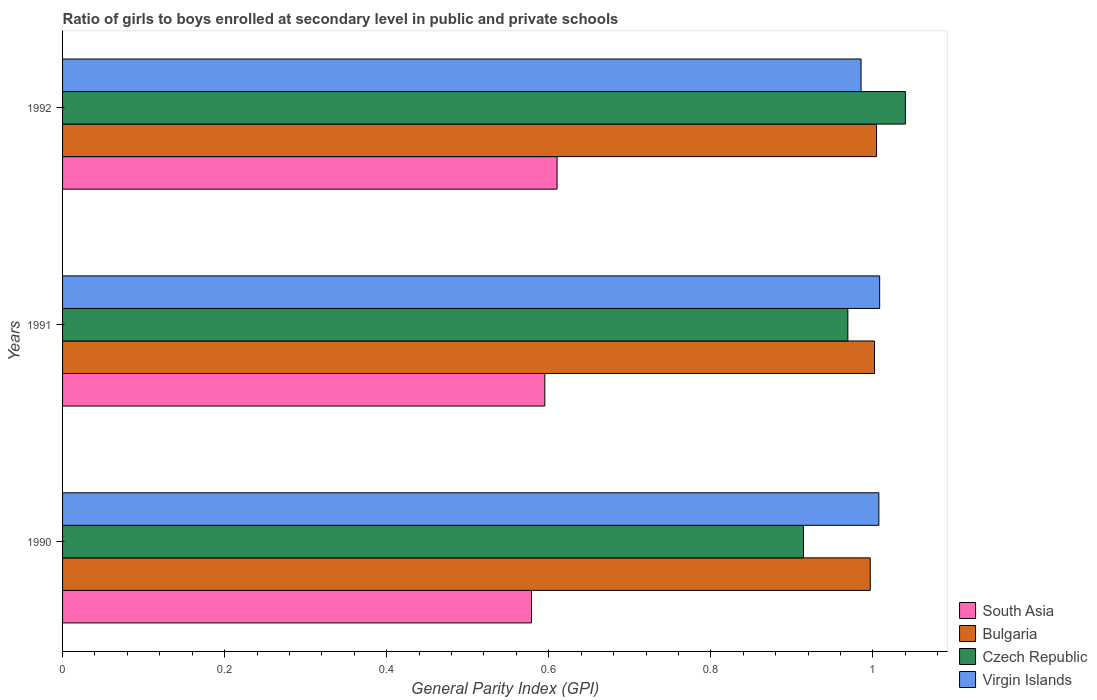How many groups of bars are there?
Your response must be concise. 3. Are the number of bars per tick equal to the number of legend labels?
Your response must be concise. Yes. How many bars are there on the 2nd tick from the bottom?
Provide a short and direct response. 4. In how many cases, is the number of bars for a given year not equal to the number of legend labels?
Your response must be concise. 0. What is the general parity index in South Asia in 1990?
Ensure brevity in your answer.  0.58. Across all years, what is the maximum general parity index in South Asia?
Offer a very short reply. 0.61. Across all years, what is the minimum general parity index in South Asia?
Your answer should be very brief. 0.58. In which year was the general parity index in Virgin Islands maximum?
Provide a succinct answer. 1991. In which year was the general parity index in Virgin Islands minimum?
Keep it short and to the point. 1992. What is the total general parity index in Bulgaria in the graph?
Ensure brevity in your answer.  3. What is the difference between the general parity index in Virgin Islands in 1990 and that in 1992?
Your answer should be compact. 0.02. What is the difference between the general parity index in Bulgaria in 1990 and the general parity index in Czech Republic in 1991?
Make the answer very short. 0.03. What is the average general parity index in Bulgaria per year?
Keep it short and to the point. 1. In the year 1992, what is the difference between the general parity index in South Asia and general parity index in Virgin Islands?
Offer a terse response. -0.38. What is the ratio of the general parity index in Bulgaria in 1990 to that in 1992?
Provide a succinct answer. 0.99. Is the general parity index in Virgin Islands in 1990 less than that in 1991?
Ensure brevity in your answer.  Yes. Is the difference between the general parity index in South Asia in 1990 and 1991 greater than the difference between the general parity index in Virgin Islands in 1990 and 1991?
Ensure brevity in your answer.  No. What is the difference between the highest and the second highest general parity index in South Asia?
Offer a terse response. 0.02. What is the difference between the highest and the lowest general parity index in Czech Republic?
Make the answer very short. 0.13. Is the sum of the general parity index in Bulgaria in 1990 and 1991 greater than the maximum general parity index in Czech Republic across all years?
Your response must be concise. Yes. What does the 2nd bar from the top in 1990 represents?
Your response must be concise. Czech Republic. How many bars are there?
Keep it short and to the point. 12. Are all the bars in the graph horizontal?
Keep it short and to the point. Yes. What is the difference between two consecutive major ticks on the X-axis?
Keep it short and to the point. 0.2. Are the values on the major ticks of X-axis written in scientific E-notation?
Provide a short and direct response. No. Does the graph contain any zero values?
Your answer should be very brief. No. How are the legend labels stacked?
Provide a short and direct response. Vertical. What is the title of the graph?
Provide a short and direct response. Ratio of girls to boys enrolled at secondary level in public and private schools. What is the label or title of the X-axis?
Give a very brief answer. General Parity Index (GPI). What is the label or title of the Y-axis?
Offer a very short reply. Years. What is the General Parity Index (GPI) in South Asia in 1990?
Your answer should be compact. 0.58. What is the General Parity Index (GPI) of Bulgaria in 1990?
Offer a very short reply. 1. What is the General Parity Index (GPI) of Czech Republic in 1990?
Give a very brief answer. 0.91. What is the General Parity Index (GPI) in Virgin Islands in 1990?
Ensure brevity in your answer.  1.01. What is the General Parity Index (GPI) of South Asia in 1991?
Give a very brief answer. 0.6. What is the General Parity Index (GPI) of Bulgaria in 1991?
Make the answer very short. 1. What is the General Parity Index (GPI) in Czech Republic in 1991?
Make the answer very short. 0.97. What is the General Parity Index (GPI) of Virgin Islands in 1991?
Provide a succinct answer. 1.01. What is the General Parity Index (GPI) of South Asia in 1992?
Ensure brevity in your answer.  0.61. What is the General Parity Index (GPI) in Bulgaria in 1992?
Provide a succinct answer. 1. What is the General Parity Index (GPI) of Czech Republic in 1992?
Give a very brief answer. 1.04. What is the General Parity Index (GPI) in Virgin Islands in 1992?
Keep it short and to the point. 0.99. Across all years, what is the maximum General Parity Index (GPI) in South Asia?
Ensure brevity in your answer.  0.61. Across all years, what is the maximum General Parity Index (GPI) of Bulgaria?
Your answer should be very brief. 1. Across all years, what is the maximum General Parity Index (GPI) of Czech Republic?
Ensure brevity in your answer.  1.04. Across all years, what is the maximum General Parity Index (GPI) of Virgin Islands?
Provide a short and direct response. 1.01. Across all years, what is the minimum General Parity Index (GPI) in South Asia?
Offer a terse response. 0.58. Across all years, what is the minimum General Parity Index (GPI) of Bulgaria?
Provide a succinct answer. 1. Across all years, what is the minimum General Parity Index (GPI) in Czech Republic?
Offer a terse response. 0.91. Across all years, what is the minimum General Parity Index (GPI) of Virgin Islands?
Ensure brevity in your answer.  0.99. What is the total General Parity Index (GPI) of South Asia in the graph?
Offer a very short reply. 1.78. What is the total General Parity Index (GPI) of Bulgaria in the graph?
Offer a very short reply. 3. What is the total General Parity Index (GPI) of Czech Republic in the graph?
Your response must be concise. 2.92. What is the total General Parity Index (GPI) of Virgin Islands in the graph?
Provide a succinct answer. 3. What is the difference between the General Parity Index (GPI) of South Asia in 1990 and that in 1991?
Your answer should be very brief. -0.02. What is the difference between the General Parity Index (GPI) in Bulgaria in 1990 and that in 1991?
Your response must be concise. -0.01. What is the difference between the General Parity Index (GPI) in Czech Republic in 1990 and that in 1991?
Your answer should be very brief. -0.05. What is the difference between the General Parity Index (GPI) of Virgin Islands in 1990 and that in 1991?
Your answer should be very brief. -0. What is the difference between the General Parity Index (GPI) in South Asia in 1990 and that in 1992?
Make the answer very short. -0.03. What is the difference between the General Parity Index (GPI) of Bulgaria in 1990 and that in 1992?
Your answer should be compact. -0.01. What is the difference between the General Parity Index (GPI) of Czech Republic in 1990 and that in 1992?
Make the answer very short. -0.13. What is the difference between the General Parity Index (GPI) of Virgin Islands in 1990 and that in 1992?
Your answer should be very brief. 0.02. What is the difference between the General Parity Index (GPI) in South Asia in 1991 and that in 1992?
Provide a short and direct response. -0.02. What is the difference between the General Parity Index (GPI) in Bulgaria in 1991 and that in 1992?
Offer a very short reply. -0. What is the difference between the General Parity Index (GPI) of Czech Republic in 1991 and that in 1992?
Provide a short and direct response. -0.07. What is the difference between the General Parity Index (GPI) of Virgin Islands in 1991 and that in 1992?
Ensure brevity in your answer.  0.02. What is the difference between the General Parity Index (GPI) of South Asia in 1990 and the General Parity Index (GPI) of Bulgaria in 1991?
Provide a succinct answer. -0.42. What is the difference between the General Parity Index (GPI) in South Asia in 1990 and the General Parity Index (GPI) in Czech Republic in 1991?
Ensure brevity in your answer.  -0.39. What is the difference between the General Parity Index (GPI) in South Asia in 1990 and the General Parity Index (GPI) in Virgin Islands in 1991?
Keep it short and to the point. -0.43. What is the difference between the General Parity Index (GPI) of Bulgaria in 1990 and the General Parity Index (GPI) of Czech Republic in 1991?
Your answer should be very brief. 0.03. What is the difference between the General Parity Index (GPI) of Bulgaria in 1990 and the General Parity Index (GPI) of Virgin Islands in 1991?
Give a very brief answer. -0.01. What is the difference between the General Parity Index (GPI) of Czech Republic in 1990 and the General Parity Index (GPI) of Virgin Islands in 1991?
Give a very brief answer. -0.09. What is the difference between the General Parity Index (GPI) of South Asia in 1990 and the General Parity Index (GPI) of Bulgaria in 1992?
Give a very brief answer. -0.43. What is the difference between the General Parity Index (GPI) in South Asia in 1990 and the General Parity Index (GPI) in Czech Republic in 1992?
Your answer should be very brief. -0.46. What is the difference between the General Parity Index (GPI) of South Asia in 1990 and the General Parity Index (GPI) of Virgin Islands in 1992?
Keep it short and to the point. -0.41. What is the difference between the General Parity Index (GPI) of Bulgaria in 1990 and the General Parity Index (GPI) of Czech Republic in 1992?
Your answer should be compact. -0.04. What is the difference between the General Parity Index (GPI) of Bulgaria in 1990 and the General Parity Index (GPI) of Virgin Islands in 1992?
Offer a terse response. 0.01. What is the difference between the General Parity Index (GPI) in Czech Republic in 1990 and the General Parity Index (GPI) in Virgin Islands in 1992?
Provide a short and direct response. -0.07. What is the difference between the General Parity Index (GPI) of South Asia in 1991 and the General Parity Index (GPI) of Bulgaria in 1992?
Give a very brief answer. -0.41. What is the difference between the General Parity Index (GPI) of South Asia in 1991 and the General Parity Index (GPI) of Czech Republic in 1992?
Provide a short and direct response. -0.45. What is the difference between the General Parity Index (GPI) of South Asia in 1991 and the General Parity Index (GPI) of Virgin Islands in 1992?
Offer a very short reply. -0.39. What is the difference between the General Parity Index (GPI) in Bulgaria in 1991 and the General Parity Index (GPI) in Czech Republic in 1992?
Your answer should be very brief. -0.04. What is the difference between the General Parity Index (GPI) of Bulgaria in 1991 and the General Parity Index (GPI) of Virgin Islands in 1992?
Make the answer very short. 0.02. What is the difference between the General Parity Index (GPI) in Czech Republic in 1991 and the General Parity Index (GPI) in Virgin Islands in 1992?
Make the answer very short. -0.02. What is the average General Parity Index (GPI) of South Asia per year?
Your answer should be very brief. 0.59. What is the average General Parity Index (GPI) in Bulgaria per year?
Make the answer very short. 1. What is the average General Parity Index (GPI) in Czech Republic per year?
Make the answer very short. 0.97. What is the average General Parity Index (GPI) in Virgin Islands per year?
Your answer should be compact. 1. In the year 1990, what is the difference between the General Parity Index (GPI) in South Asia and General Parity Index (GPI) in Bulgaria?
Offer a terse response. -0.42. In the year 1990, what is the difference between the General Parity Index (GPI) in South Asia and General Parity Index (GPI) in Czech Republic?
Provide a short and direct response. -0.34. In the year 1990, what is the difference between the General Parity Index (GPI) of South Asia and General Parity Index (GPI) of Virgin Islands?
Your answer should be very brief. -0.43. In the year 1990, what is the difference between the General Parity Index (GPI) in Bulgaria and General Parity Index (GPI) in Czech Republic?
Offer a very short reply. 0.08. In the year 1990, what is the difference between the General Parity Index (GPI) of Bulgaria and General Parity Index (GPI) of Virgin Islands?
Offer a terse response. -0.01. In the year 1990, what is the difference between the General Parity Index (GPI) of Czech Republic and General Parity Index (GPI) of Virgin Islands?
Offer a terse response. -0.09. In the year 1991, what is the difference between the General Parity Index (GPI) of South Asia and General Parity Index (GPI) of Bulgaria?
Give a very brief answer. -0.41. In the year 1991, what is the difference between the General Parity Index (GPI) of South Asia and General Parity Index (GPI) of Czech Republic?
Your answer should be very brief. -0.37. In the year 1991, what is the difference between the General Parity Index (GPI) in South Asia and General Parity Index (GPI) in Virgin Islands?
Provide a short and direct response. -0.41. In the year 1991, what is the difference between the General Parity Index (GPI) of Bulgaria and General Parity Index (GPI) of Czech Republic?
Your response must be concise. 0.03. In the year 1991, what is the difference between the General Parity Index (GPI) of Bulgaria and General Parity Index (GPI) of Virgin Islands?
Offer a terse response. -0.01. In the year 1991, what is the difference between the General Parity Index (GPI) in Czech Republic and General Parity Index (GPI) in Virgin Islands?
Provide a succinct answer. -0.04. In the year 1992, what is the difference between the General Parity Index (GPI) in South Asia and General Parity Index (GPI) in Bulgaria?
Your answer should be very brief. -0.39. In the year 1992, what is the difference between the General Parity Index (GPI) of South Asia and General Parity Index (GPI) of Czech Republic?
Keep it short and to the point. -0.43. In the year 1992, what is the difference between the General Parity Index (GPI) in South Asia and General Parity Index (GPI) in Virgin Islands?
Provide a short and direct response. -0.38. In the year 1992, what is the difference between the General Parity Index (GPI) of Bulgaria and General Parity Index (GPI) of Czech Republic?
Ensure brevity in your answer.  -0.04. In the year 1992, what is the difference between the General Parity Index (GPI) of Bulgaria and General Parity Index (GPI) of Virgin Islands?
Offer a very short reply. 0.02. In the year 1992, what is the difference between the General Parity Index (GPI) in Czech Republic and General Parity Index (GPI) in Virgin Islands?
Provide a succinct answer. 0.05. What is the ratio of the General Parity Index (GPI) in South Asia in 1990 to that in 1991?
Your answer should be very brief. 0.97. What is the ratio of the General Parity Index (GPI) in Bulgaria in 1990 to that in 1991?
Provide a succinct answer. 0.99. What is the ratio of the General Parity Index (GPI) of Czech Republic in 1990 to that in 1991?
Make the answer very short. 0.94. What is the ratio of the General Parity Index (GPI) in Virgin Islands in 1990 to that in 1991?
Provide a succinct answer. 1. What is the ratio of the General Parity Index (GPI) of South Asia in 1990 to that in 1992?
Make the answer very short. 0.95. What is the ratio of the General Parity Index (GPI) of Bulgaria in 1990 to that in 1992?
Provide a short and direct response. 0.99. What is the ratio of the General Parity Index (GPI) of Czech Republic in 1990 to that in 1992?
Your response must be concise. 0.88. What is the ratio of the General Parity Index (GPI) of Virgin Islands in 1990 to that in 1992?
Keep it short and to the point. 1.02. What is the ratio of the General Parity Index (GPI) in South Asia in 1991 to that in 1992?
Your answer should be compact. 0.98. What is the ratio of the General Parity Index (GPI) of Bulgaria in 1991 to that in 1992?
Your answer should be compact. 1. What is the ratio of the General Parity Index (GPI) in Czech Republic in 1991 to that in 1992?
Ensure brevity in your answer.  0.93. What is the ratio of the General Parity Index (GPI) of Virgin Islands in 1991 to that in 1992?
Keep it short and to the point. 1.02. What is the difference between the highest and the second highest General Parity Index (GPI) of South Asia?
Keep it short and to the point. 0.02. What is the difference between the highest and the second highest General Parity Index (GPI) of Bulgaria?
Provide a short and direct response. 0. What is the difference between the highest and the second highest General Parity Index (GPI) in Czech Republic?
Make the answer very short. 0.07. What is the difference between the highest and the second highest General Parity Index (GPI) in Virgin Islands?
Give a very brief answer. 0. What is the difference between the highest and the lowest General Parity Index (GPI) of South Asia?
Give a very brief answer. 0.03. What is the difference between the highest and the lowest General Parity Index (GPI) in Bulgaria?
Give a very brief answer. 0.01. What is the difference between the highest and the lowest General Parity Index (GPI) in Czech Republic?
Your response must be concise. 0.13. What is the difference between the highest and the lowest General Parity Index (GPI) of Virgin Islands?
Give a very brief answer. 0.02. 